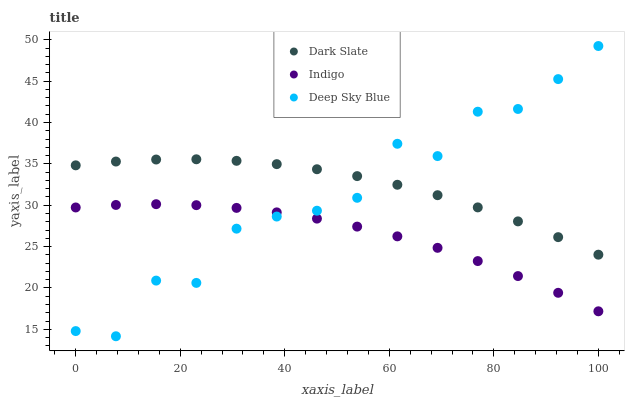Does Indigo have the minimum area under the curve?
Answer yes or no. Yes. Does Dark Slate have the maximum area under the curve?
Answer yes or no. Yes. Does Deep Sky Blue have the minimum area under the curve?
Answer yes or no. No. Does Deep Sky Blue have the maximum area under the curve?
Answer yes or no. No. Is Indigo the smoothest?
Answer yes or no. Yes. Is Deep Sky Blue the roughest?
Answer yes or no. Yes. Is Deep Sky Blue the smoothest?
Answer yes or no. No. Is Indigo the roughest?
Answer yes or no. No. Does Deep Sky Blue have the lowest value?
Answer yes or no. Yes. Does Indigo have the lowest value?
Answer yes or no. No. Does Deep Sky Blue have the highest value?
Answer yes or no. Yes. Does Indigo have the highest value?
Answer yes or no. No. Is Indigo less than Dark Slate?
Answer yes or no. Yes. Is Dark Slate greater than Indigo?
Answer yes or no. Yes. Does Deep Sky Blue intersect Dark Slate?
Answer yes or no. Yes. Is Deep Sky Blue less than Dark Slate?
Answer yes or no. No. Is Deep Sky Blue greater than Dark Slate?
Answer yes or no. No. Does Indigo intersect Dark Slate?
Answer yes or no. No. 